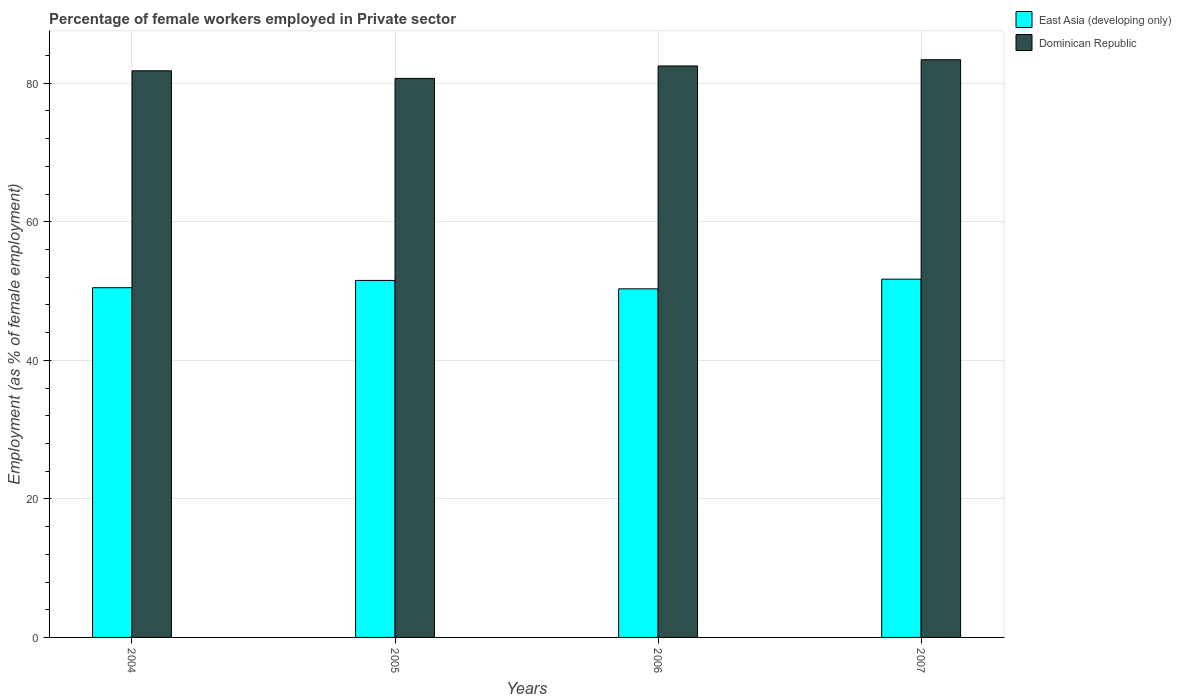How many groups of bars are there?
Offer a terse response. 4. What is the percentage of females employed in Private sector in East Asia (developing only) in 2006?
Your response must be concise. 50.32. Across all years, what is the maximum percentage of females employed in Private sector in Dominican Republic?
Your answer should be very brief. 83.4. Across all years, what is the minimum percentage of females employed in Private sector in Dominican Republic?
Your answer should be compact. 80.7. In which year was the percentage of females employed in Private sector in East Asia (developing only) maximum?
Your response must be concise. 2007. In which year was the percentage of females employed in Private sector in East Asia (developing only) minimum?
Offer a very short reply. 2006. What is the total percentage of females employed in Private sector in East Asia (developing only) in the graph?
Offer a very short reply. 204.06. What is the difference between the percentage of females employed in Private sector in Dominican Republic in 2004 and that in 2007?
Keep it short and to the point. -1.6. What is the difference between the percentage of females employed in Private sector in East Asia (developing only) in 2007 and the percentage of females employed in Private sector in Dominican Republic in 2006?
Give a very brief answer. -30.78. What is the average percentage of females employed in Private sector in East Asia (developing only) per year?
Provide a short and direct response. 51.02. In the year 2005, what is the difference between the percentage of females employed in Private sector in East Asia (developing only) and percentage of females employed in Private sector in Dominican Republic?
Provide a succinct answer. -29.16. In how many years, is the percentage of females employed in Private sector in East Asia (developing only) greater than 64 %?
Make the answer very short. 0. What is the ratio of the percentage of females employed in Private sector in Dominican Republic in 2004 to that in 2005?
Give a very brief answer. 1.01. Is the percentage of females employed in Private sector in Dominican Republic in 2006 less than that in 2007?
Your answer should be compact. Yes. What is the difference between the highest and the second highest percentage of females employed in Private sector in Dominican Republic?
Your answer should be compact. 0.9. What is the difference between the highest and the lowest percentage of females employed in Private sector in East Asia (developing only)?
Provide a short and direct response. 1.39. What does the 1st bar from the left in 2005 represents?
Make the answer very short. East Asia (developing only). What does the 2nd bar from the right in 2006 represents?
Give a very brief answer. East Asia (developing only). How many bars are there?
Your answer should be very brief. 8. What is the difference between two consecutive major ticks on the Y-axis?
Provide a succinct answer. 20. Are the values on the major ticks of Y-axis written in scientific E-notation?
Provide a short and direct response. No. Does the graph contain grids?
Give a very brief answer. Yes. Where does the legend appear in the graph?
Your response must be concise. Top right. How are the legend labels stacked?
Your answer should be very brief. Vertical. What is the title of the graph?
Give a very brief answer. Percentage of female workers employed in Private sector. What is the label or title of the X-axis?
Ensure brevity in your answer.  Years. What is the label or title of the Y-axis?
Give a very brief answer. Employment (as % of female employment). What is the Employment (as % of female employment) of East Asia (developing only) in 2004?
Ensure brevity in your answer.  50.49. What is the Employment (as % of female employment) in Dominican Republic in 2004?
Your answer should be very brief. 81.8. What is the Employment (as % of female employment) of East Asia (developing only) in 2005?
Offer a very short reply. 51.54. What is the Employment (as % of female employment) in Dominican Republic in 2005?
Give a very brief answer. 80.7. What is the Employment (as % of female employment) in East Asia (developing only) in 2006?
Make the answer very short. 50.32. What is the Employment (as % of female employment) in Dominican Republic in 2006?
Your answer should be very brief. 82.5. What is the Employment (as % of female employment) of East Asia (developing only) in 2007?
Offer a terse response. 51.72. What is the Employment (as % of female employment) in Dominican Republic in 2007?
Offer a very short reply. 83.4. Across all years, what is the maximum Employment (as % of female employment) of East Asia (developing only)?
Offer a very short reply. 51.72. Across all years, what is the maximum Employment (as % of female employment) of Dominican Republic?
Provide a succinct answer. 83.4. Across all years, what is the minimum Employment (as % of female employment) in East Asia (developing only)?
Provide a short and direct response. 50.32. Across all years, what is the minimum Employment (as % of female employment) in Dominican Republic?
Your answer should be very brief. 80.7. What is the total Employment (as % of female employment) of East Asia (developing only) in the graph?
Your answer should be compact. 204.06. What is the total Employment (as % of female employment) of Dominican Republic in the graph?
Your answer should be very brief. 328.4. What is the difference between the Employment (as % of female employment) of East Asia (developing only) in 2004 and that in 2005?
Your response must be concise. -1.05. What is the difference between the Employment (as % of female employment) in East Asia (developing only) in 2004 and that in 2006?
Ensure brevity in your answer.  0.16. What is the difference between the Employment (as % of female employment) in Dominican Republic in 2004 and that in 2006?
Your answer should be compact. -0.7. What is the difference between the Employment (as % of female employment) of East Asia (developing only) in 2004 and that in 2007?
Ensure brevity in your answer.  -1.23. What is the difference between the Employment (as % of female employment) in Dominican Republic in 2004 and that in 2007?
Ensure brevity in your answer.  -1.6. What is the difference between the Employment (as % of female employment) in East Asia (developing only) in 2005 and that in 2006?
Make the answer very short. 1.21. What is the difference between the Employment (as % of female employment) in East Asia (developing only) in 2005 and that in 2007?
Ensure brevity in your answer.  -0.18. What is the difference between the Employment (as % of female employment) of East Asia (developing only) in 2006 and that in 2007?
Offer a terse response. -1.39. What is the difference between the Employment (as % of female employment) of Dominican Republic in 2006 and that in 2007?
Your answer should be very brief. -0.9. What is the difference between the Employment (as % of female employment) of East Asia (developing only) in 2004 and the Employment (as % of female employment) of Dominican Republic in 2005?
Provide a short and direct response. -30.21. What is the difference between the Employment (as % of female employment) of East Asia (developing only) in 2004 and the Employment (as % of female employment) of Dominican Republic in 2006?
Provide a short and direct response. -32.01. What is the difference between the Employment (as % of female employment) of East Asia (developing only) in 2004 and the Employment (as % of female employment) of Dominican Republic in 2007?
Your answer should be compact. -32.91. What is the difference between the Employment (as % of female employment) of East Asia (developing only) in 2005 and the Employment (as % of female employment) of Dominican Republic in 2006?
Your answer should be very brief. -30.96. What is the difference between the Employment (as % of female employment) of East Asia (developing only) in 2005 and the Employment (as % of female employment) of Dominican Republic in 2007?
Provide a short and direct response. -31.86. What is the difference between the Employment (as % of female employment) of East Asia (developing only) in 2006 and the Employment (as % of female employment) of Dominican Republic in 2007?
Offer a terse response. -33.08. What is the average Employment (as % of female employment) of East Asia (developing only) per year?
Your answer should be compact. 51.02. What is the average Employment (as % of female employment) of Dominican Republic per year?
Ensure brevity in your answer.  82.1. In the year 2004, what is the difference between the Employment (as % of female employment) of East Asia (developing only) and Employment (as % of female employment) of Dominican Republic?
Make the answer very short. -31.31. In the year 2005, what is the difference between the Employment (as % of female employment) of East Asia (developing only) and Employment (as % of female employment) of Dominican Republic?
Your answer should be very brief. -29.16. In the year 2006, what is the difference between the Employment (as % of female employment) of East Asia (developing only) and Employment (as % of female employment) of Dominican Republic?
Offer a very short reply. -32.18. In the year 2007, what is the difference between the Employment (as % of female employment) of East Asia (developing only) and Employment (as % of female employment) of Dominican Republic?
Your answer should be very brief. -31.68. What is the ratio of the Employment (as % of female employment) of East Asia (developing only) in 2004 to that in 2005?
Your response must be concise. 0.98. What is the ratio of the Employment (as % of female employment) in Dominican Republic in 2004 to that in 2005?
Make the answer very short. 1.01. What is the ratio of the Employment (as % of female employment) of East Asia (developing only) in 2004 to that in 2007?
Your response must be concise. 0.98. What is the ratio of the Employment (as % of female employment) of Dominican Republic in 2004 to that in 2007?
Your answer should be very brief. 0.98. What is the ratio of the Employment (as % of female employment) in East Asia (developing only) in 2005 to that in 2006?
Provide a short and direct response. 1.02. What is the ratio of the Employment (as % of female employment) in Dominican Republic in 2005 to that in 2006?
Your answer should be compact. 0.98. What is the ratio of the Employment (as % of female employment) of Dominican Republic in 2005 to that in 2007?
Provide a succinct answer. 0.97. What is the ratio of the Employment (as % of female employment) in East Asia (developing only) in 2006 to that in 2007?
Provide a succinct answer. 0.97. What is the ratio of the Employment (as % of female employment) of Dominican Republic in 2006 to that in 2007?
Keep it short and to the point. 0.99. What is the difference between the highest and the second highest Employment (as % of female employment) of East Asia (developing only)?
Offer a very short reply. 0.18. What is the difference between the highest and the lowest Employment (as % of female employment) in East Asia (developing only)?
Give a very brief answer. 1.39. 